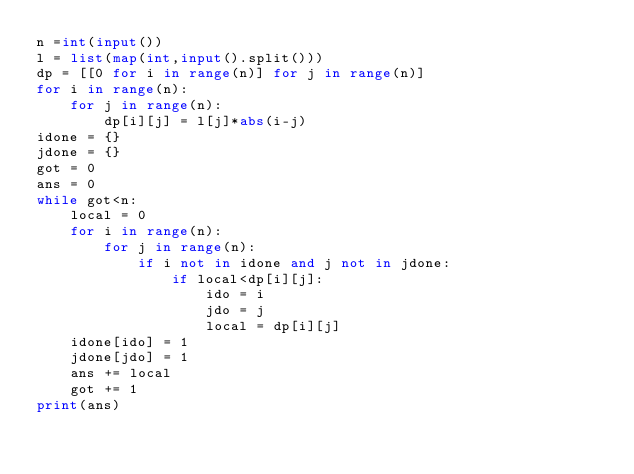Convert code to text. <code><loc_0><loc_0><loc_500><loc_500><_Python_>n =int(input())
l = list(map(int,input().split()))
dp = [[0 for i in range(n)] for j in range(n)]
for i in range(n):
    for j in range(n):
        dp[i][j] = l[j]*abs(i-j)
idone = {}
jdone = {}
got = 0
ans = 0
while got<n:
    local = 0
    for i in range(n):
        for j in range(n):
            if i not in idone and j not in jdone:
                if local<dp[i][j]:
                    ido = i
                    jdo = j
                    local = dp[i][j]
    idone[ido] = 1
    jdone[jdo] = 1
    ans += local
    got += 1
print(ans)</code> 